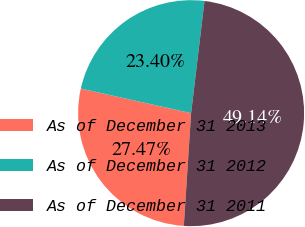Convert chart to OTSL. <chart><loc_0><loc_0><loc_500><loc_500><pie_chart><fcel>As of December 31 2013<fcel>As of December 31 2012<fcel>As of December 31 2011<nl><fcel>27.47%<fcel>23.4%<fcel>49.14%<nl></chart> 